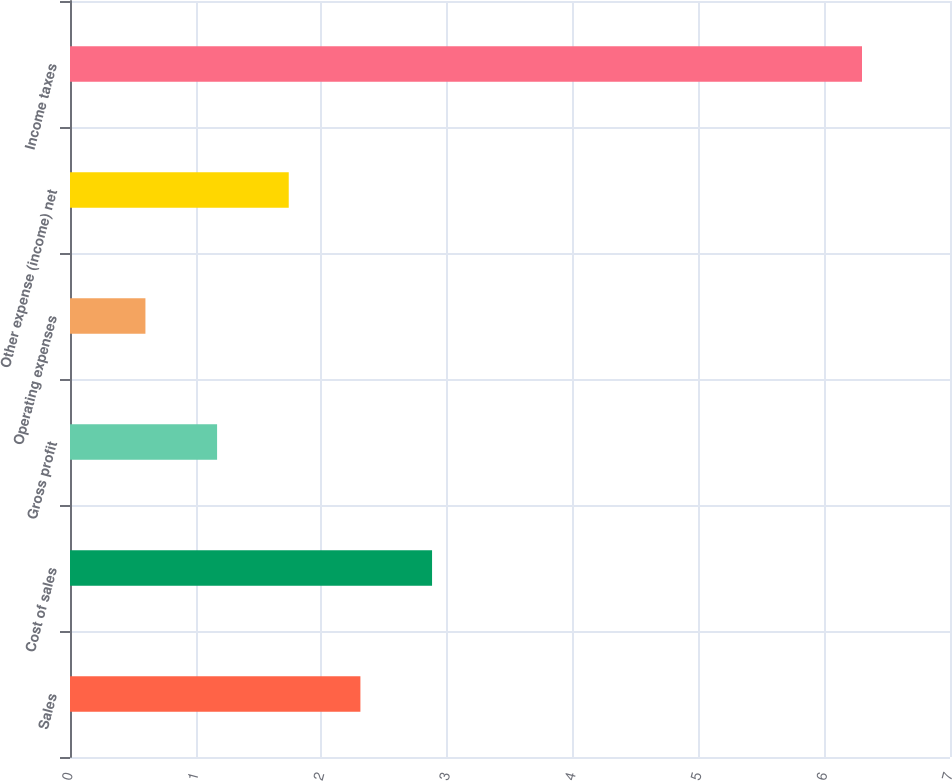Convert chart to OTSL. <chart><loc_0><loc_0><loc_500><loc_500><bar_chart><fcel>Sales<fcel>Cost of sales<fcel>Gross profit<fcel>Operating expenses<fcel>Other expense (income) net<fcel>Income taxes<nl><fcel>2.31<fcel>2.88<fcel>1.17<fcel>0.6<fcel>1.74<fcel>6.3<nl></chart> 